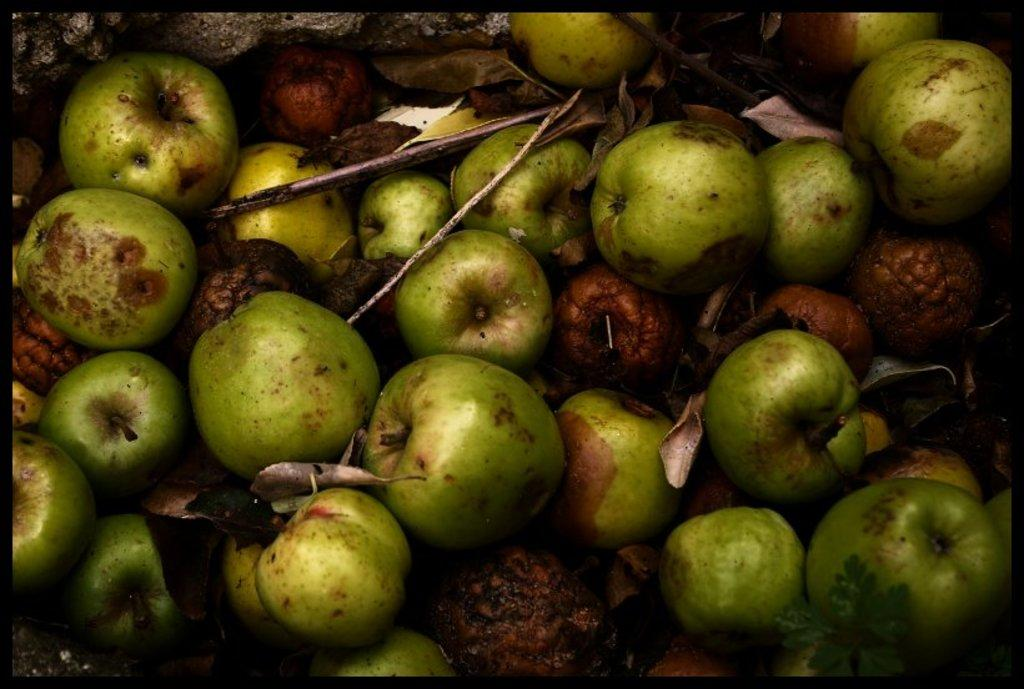What type of food items are present in the image? There are fruits in the image. What is the color of the fruits? The fruits are green in color. What other objects can be seen in the image? There are dried leaves in the image. What type of iron object can be seen in the image? There is no iron object present in the image. Is there a light source visible in the image? The provided facts do not mention a light source, so it cannot be determined from the image. 